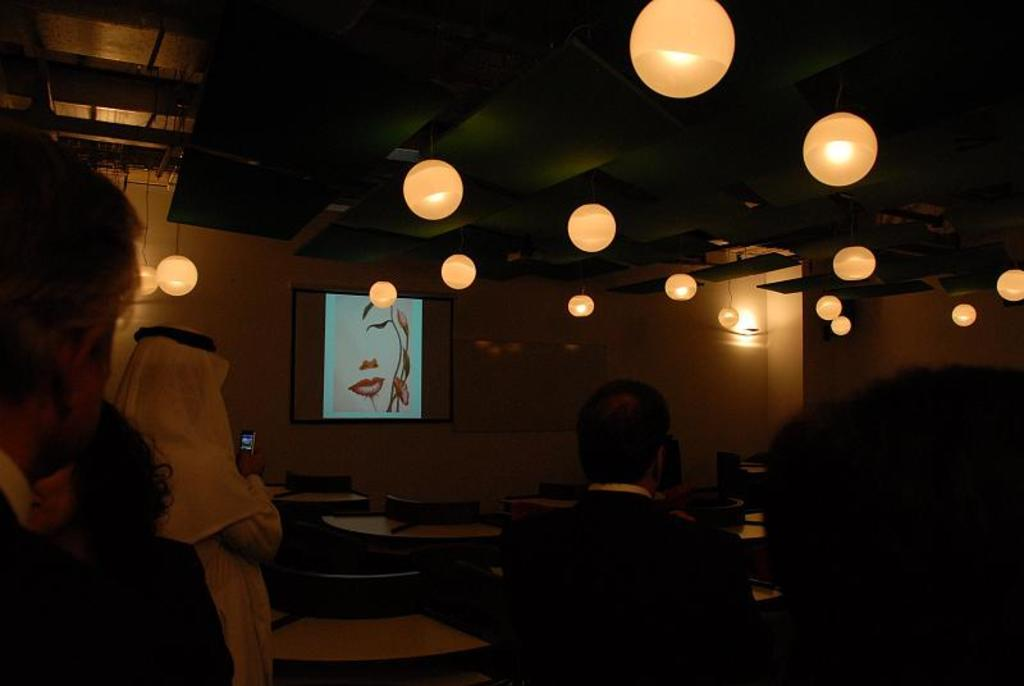What are the people in the image doing? There are people sitting on chairs and standing in the image. What are the people looking at? The people are looking towards a screen. How is the screen being displayed? The screen is projected. Can you describe the lighting in the image? The lighting in the image is dim. What type of curve can be seen on the quarter in the image? There is no quarter present in the image, so it is not possible to determine if there is a curve on it. 